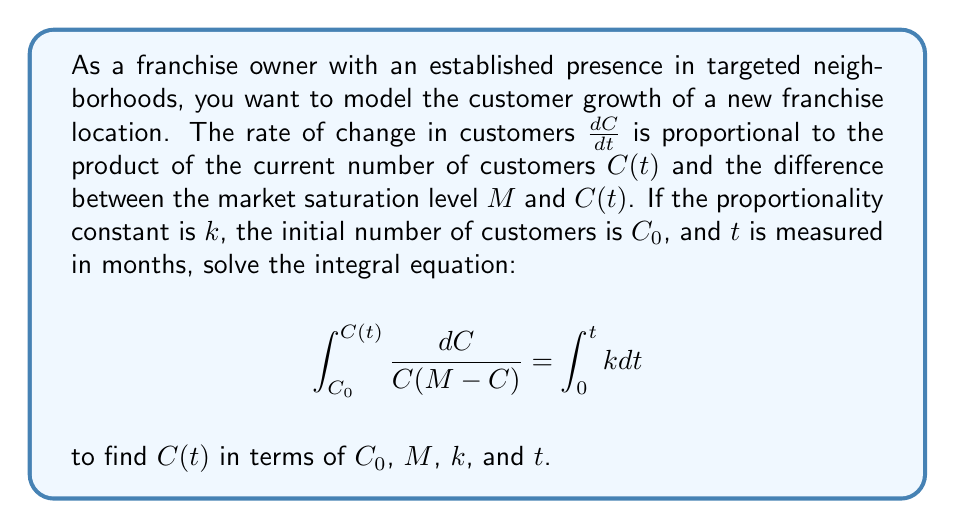Show me your answer to this math problem. Let's solve this integral equation step by step:

1) First, let's solve the left-hand side of the equation:
   $$\int_{C_0}^{C(t)} \frac{dC}{C(M-C)}$$
   
   This is a partial fraction decomposition. We can rewrite it as:
   $$\int_{C_0}^{C(t)} (\frac{1}{MC} + \frac{1}{M(M-C)}) dC$$

2) Integrating both parts:
   $$[\frac{1}{M}\ln|C| - \frac{1}{M}\ln|M-C|]_{C_0}^{C(t)}$$

3) Evaluating the integral:
   $$\frac{1}{M}(\ln|C(t)| - \ln|M-C(t)|) - \frac{1}{M}(\ln|C_0| - \ln|M-C_0|)$$

4) This simplifies to:
   $$\frac{1}{M}\ln|\frac{C(t)(M-C_0)}{C_0(M-C(t))}|$$

5) Now, let's solve the right-hand side of the equation:
   $$\int_0^t k dt = kt$$

6) Equating both sides:
   $$\frac{1}{M}\ln|\frac{C(t)(M-C_0)}{C_0(M-C(t))}| = kt$$

7) Multiply both sides by $M$:
   $$\ln|\frac{C(t)(M-C_0)}{C_0(M-C(t))}| = Mkt$$

8) Take $e$ to the power of both sides:
   $$\frac{C(t)(M-C_0)}{C_0(M-C(t))} = e^{Mkt}$$

9) Cross multiply:
   $$C(t)(M-C_0) = C_0(M-C(t))e^{Mkt}$$

10) Expand:
    $$MC(t) - C(t)C_0 = MC_0e^{Mkt} - C_0C(t)e^{Mkt}$$

11) Collect $C(t)$ terms:
    $$C(t)(M + C_0e^{Mkt}) = MC_0e^{Mkt}$$

12) Solve for $C(t)$:
    $$C(t) = \frac{MC_0e^{Mkt}}{M + C_0e^{Mkt}}$$

This is our final solution for $C(t)$.
Answer: $C(t) = \frac{MC_0e^{Mkt}}{M + C_0e^{Mkt}}$ 